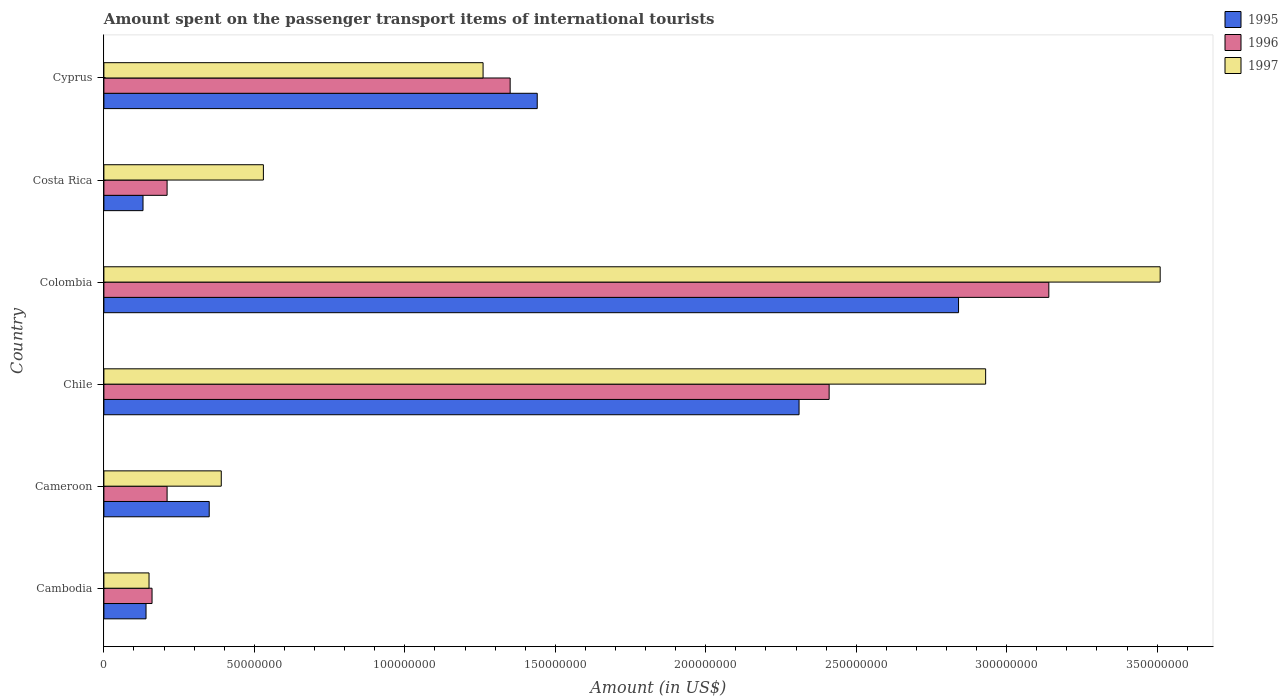How many groups of bars are there?
Offer a terse response. 6. Are the number of bars per tick equal to the number of legend labels?
Offer a terse response. Yes. How many bars are there on the 6th tick from the top?
Offer a very short reply. 3. How many bars are there on the 2nd tick from the bottom?
Offer a very short reply. 3. What is the label of the 5th group of bars from the top?
Make the answer very short. Cameroon. What is the amount spent on the passenger transport items of international tourists in 1995 in Chile?
Your answer should be very brief. 2.31e+08. Across all countries, what is the maximum amount spent on the passenger transport items of international tourists in 1996?
Your answer should be very brief. 3.14e+08. Across all countries, what is the minimum amount spent on the passenger transport items of international tourists in 1997?
Provide a succinct answer. 1.50e+07. In which country was the amount spent on the passenger transport items of international tourists in 1996 maximum?
Provide a succinct answer. Colombia. In which country was the amount spent on the passenger transport items of international tourists in 1997 minimum?
Ensure brevity in your answer.  Cambodia. What is the total amount spent on the passenger transport items of international tourists in 1995 in the graph?
Make the answer very short. 7.21e+08. What is the difference between the amount spent on the passenger transport items of international tourists in 1996 in Cameroon and that in Colombia?
Offer a terse response. -2.93e+08. What is the difference between the amount spent on the passenger transport items of international tourists in 1995 in Cyprus and the amount spent on the passenger transport items of international tourists in 1996 in Cambodia?
Give a very brief answer. 1.28e+08. What is the average amount spent on the passenger transport items of international tourists in 1995 per country?
Make the answer very short. 1.20e+08. What is the difference between the amount spent on the passenger transport items of international tourists in 1996 and amount spent on the passenger transport items of international tourists in 1995 in Cameroon?
Keep it short and to the point. -1.40e+07. In how many countries, is the amount spent on the passenger transport items of international tourists in 1996 greater than 90000000 US$?
Your answer should be compact. 3. What is the ratio of the amount spent on the passenger transport items of international tourists in 1997 in Cambodia to that in Cameroon?
Provide a short and direct response. 0.38. Is the difference between the amount spent on the passenger transport items of international tourists in 1996 in Cambodia and Cameroon greater than the difference between the amount spent on the passenger transport items of international tourists in 1995 in Cambodia and Cameroon?
Provide a short and direct response. Yes. What is the difference between the highest and the second highest amount spent on the passenger transport items of international tourists in 1997?
Keep it short and to the point. 5.80e+07. What is the difference between the highest and the lowest amount spent on the passenger transport items of international tourists in 1995?
Your answer should be compact. 2.71e+08. What does the 1st bar from the top in Colombia represents?
Offer a very short reply. 1997. What does the 1st bar from the bottom in Cameroon represents?
Your answer should be very brief. 1995. Is it the case that in every country, the sum of the amount spent on the passenger transport items of international tourists in 1996 and amount spent on the passenger transport items of international tourists in 1997 is greater than the amount spent on the passenger transport items of international tourists in 1995?
Provide a succinct answer. Yes. How many bars are there?
Give a very brief answer. 18. Are all the bars in the graph horizontal?
Provide a succinct answer. Yes. Are the values on the major ticks of X-axis written in scientific E-notation?
Ensure brevity in your answer.  No. Does the graph contain any zero values?
Ensure brevity in your answer.  No. Where does the legend appear in the graph?
Offer a terse response. Top right. How many legend labels are there?
Provide a succinct answer. 3. What is the title of the graph?
Offer a terse response. Amount spent on the passenger transport items of international tourists. What is the label or title of the Y-axis?
Offer a terse response. Country. What is the Amount (in US$) of 1995 in Cambodia?
Provide a succinct answer. 1.40e+07. What is the Amount (in US$) in 1996 in Cambodia?
Make the answer very short. 1.60e+07. What is the Amount (in US$) in 1997 in Cambodia?
Your answer should be very brief. 1.50e+07. What is the Amount (in US$) in 1995 in Cameroon?
Keep it short and to the point. 3.50e+07. What is the Amount (in US$) in 1996 in Cameroon?
Your answer should be compact. 2.10e+07. What is the Amount (in US$) of 1997 in Cameroon?
Make the answer very short. 3.90e+07. What is the Amount (in US$) in 1995 in Chile?
Give a very brief answer. 2.31e+08. What is the Amount (in US$) in 1996 in Chile?
Your answer should be compact. 2.41e+08. What is the Amount (in US$) of 1997 in Chile?
Provide a short and direct response. 2.93e+08. What is the Amount (in US$) in 1995 in Colombia?
Your answer should be very brief. 2.84e+08. What is the Amount (in US$) of 1996 in Colombia?
Ensure brevity in your answer.  3.14e+08. What is the Amount (in US$) of 1997 in Colombia?
Offer a terse response. 3.51e+08. What is the Amount (in US$) of 1995 in Costa Rica?
Give a very brief answer. 1.30e+07. What is the Amount (in US$) in 1996 in Costa Rica?
Your answer should be very brief. 2.10e+07. What is the Amount (in US$) in 1997 in Costa Rica?
Provide a short and direct response. 5.30e+07. What is the Amount (in US$) of 1995 in Cyprus?
Your answer should be compact. 1.44e+08. What is the Amount (in US$) in 1996 in Cyprus?
Your response must be concise. 1.35e+08. What is the Amount (in US$) of 1997 in Cyprus?
Provide a short and direct response. 1.26e+08. Across all countries, what is the maximum Amount (in US$) of 1995?
Your answer should be very brief. 2.84e+08. Across all countries, what is the maximum Amount (in US$) in 1996?
Offer a terse response. 3.14e+08. Across all countries, what is the maximum Amount (in US$) in 1997?
Keep it short and to the point. 3.51e+08. Across all countries, what is the minimum Amount (in US$) in 1995?
Provide a succinct answer. 1.30e+07. Across all countries, what is the minimum Amount (in US$) of 1996?
Give a very brief answer. 1.60e+07. Across all countries, what is the minimum Amount (in US$) in 1997?
Your response must be concise. 1.50e+07. What is the total Amount (in US$) of 1995 in the graph?
Your answer should be very brief. 7.21e+08. What is the total Amount (in US$) of 1996 in the graph?
Provide a succinct answer. 7.48e+08. What is the total Amount (in US$) in 1997 in the graph?
Provide a succinct answer. 8.77e+08. What is the difference between the Amount (in US$) in 1995 in Cambodia and that in Cameroon?
Ensure brevity in your answer.  -2.10e+07. What is the difference between the Amount (in US$) of 1996 in Cambodia and that in Cameroon?
Your answer should be very brief. -5.00e+06. What is the difference between the Amount (in US$) in 1997 in Cambodia and that in Cameroon?
Your answer should be very brief. -2.40e+07. What is the difference between the Amount (in US$) of 1995 in Cambodia and that in Chile?
Your response must be concise. -2.17e+08. What is the difference between the Amount (in US$) of 1996 in Cambodia and that in Chile?
Give a very brief answer. -2.25e+08. What is the difference between the Amount (in US$) in 1997 in Cambodia and that in Chile?
Provide a succinct answer. -2.78e+08. What is the difference between the Amount (in US$) of 1995 in Cambodia and that in Colombia?
Your answer should be compact. -2.70e+08. What is the difference between the Amount (in US$) in 1996 in Cambodia and that in Colombia?
Provide a succinct answer. -2.98e+08. What is the difference between the Amount (in US$) in 1997 in Cambodia and that in Colombia?
Keep it short and to the point. -3.36e+08. What is the difference between the Amount (in US$) in 1996 in Cambodia and that in Costa Rica?
Give a very brief answer. -5.00e+06. What is the difference between the Amount (in US$) of 1997 in Cambodia and that in Costa Rica?
Offer a terse response. -3.80e+07. What is the difference between the Amount (in US$) of 1995 in Cambodia and that in Cyprus?
Offer a terse response. -1.30e+08. What is the difference between the Amount (in US$) of 1996 in Cambodia and that in Cyprus?
Your answer should be very brief. -1.19e+08. What is the difference between the Amount (in US$) in 1997 in Cambodia and that in Cyprus?
Provide a succinct answer. -1.11e+08. What is the difference between the Amount (in US$) of 1995 in Cameroon and that in Chile?
Keep it short and to the point. -1.96e+08. What is the difference between the Amount (in US$) of 1996 in Cameroon and that in Chile?
Give a very brief answer. -2.20e+08. What is the difference between the Amount (in US$) in 1997 in Cameroon and that in Chile?
Ensure brevity in your answer.  -2.54e+08. What is the difference between the Amount (in US$) of 1995 in Cameroon and that in Colombia?
Offer a very short reply. -2.49e+08. What is the difference between the Amount (in US$) in 1996 in Cameroon and that in Colombia?
Make the answer very short. -2.93e+08. What is the difference between the Amount (in US$) of 1997 in Cameroon and that in Colombia?
Ensure brevity in your answer.  -3.12e+08. What is the difference between the Amount (in US$) of 1995 in Cameroon and that in Costa Rica?
Your answer should be compact. 2.20e+07. What is the difference between the Amount (in US$) in 1996 in Cameroon and that in Costa Rica?
Your answer should be compact. 0. What is the difference between the Amount (in US$) in 1997 in Cameroon and that in Costa Rica?
Provide a short and direct response. -1.40e+07. What is the difference between the Amount (in US$) in 1995 in Cameroon and that in Cyprus?
Your response must be concise. -1.09e+08. What is the difference between the Amount (in US$) in 1996 in Cameroon and that in Cyprus?
Offer a terse response. -1.14e+08. What is the difference between the Amount (in US$) in 1997 in Cameroon and that in Cyprus?
Keep it short and to the point. -8.70e+07. What is the difference between the Amount (in US$) of 1995 in Chile and that in Colombia?
Give a very brief answer. -5.30e+07. What is the difference between the Amount (in US$) in 1996 in Chile and that in Colombia?
Provide a succinct answer. -7.30e+07. What is the difference between the Amount (in US$) in 1997 in Chile and that in Colombia?
Your response must be concise. -5.80e+07. What is the difference between the Amount (in US$) of 1995 in Chile and that in Costa Rica?
Make the answer very short. 2.18e+08. What is the difference between the Amount (in US$) in 1996 in Chile and that in Costa Rica?
Give a very brief answer. 2.20e+08. What is the difference between the Amount (in US$) in 1997 in Chile and that in Costa Rica?
Your response must be concise. 2.40e+08. What is the difference between the Amount (in US$) in 1995 in Chile and that in Cyprus?
Offer a terse response. 8.70e+07. What is the difference between the Amount (in US$) of 1996 in Chile and that in Cyprus?
Offer a very short reply. 1.06e+08. What is the difference between the Amount (in US$) in 1997 in Chile and that in Cyprus?
Provide a short and direct response. 1.67e+08. What is the difference between the Amount (in US$) of 1995 in Colombia and that in Costa Rica?
Give a very brief answer. 2.71e+08. What is the difference between the Amount (in US$) of 1996 in Colombia and that in Costa Rica?
Your answer should be compact. 2.93e+08. What is the difference between the Amount (in US$) in 1997 in Colombia and that in Costa Rica?
Make the answer very short. 2.98e+08. What is the difference between the Amount (in US$) of 1995 in Colombia and that in Cyprus?
Make the answer very short. 1.40e+08. What is the difference between the Amount (in US$) of 1996 in Colombia and that in Cyprus?
Keep it short and to the point. 1.79e+08. What is the difference between the Amount (in US$) of 1997 in Colombia and that in Cyprus?
Offer a very short reply. 2.25e+08. What is the difference between the Amount (in US$) in 1995 in Costa Rica and that in Cyprus?
Your response must be concise. -1.31e+08. What is the difference between the Amount (in US$) in 1996 in Costa Rica and that in Cyprus?
Offer a very short reply. -1.14e+08. What is the difference between the Amount (in US$) in 1997 in Costa Rica and that in Cyprus?
Your answer should be compact. -7.30e+07. What is the difference between the Amount (in US$) of 1995 in Cambodia and the Amount (in US$) of 1996 in Cameroon?
Your answer should be very brief. -7.00e+06. What is the difference between the Amount (in US$) of 1995 in Cambodia and the Amount (in US$) of 1997 in Cameroon?
Your answer should be very brief. -2.50e+07. What is the difference between the Amount (in US$) of 1996 in Cambodia and the Amount (in US$) of 1997 in Cameroon?
Offer a very short reply. -2.30e+07. What is the difference between the Amount (in US$) of 1995 in Cambodia and the Amount (in US$) of 1996 in Chile?
Provide a succinct answer. -2.27e+08. What is the difference between the Amount (in US$) of 1995 in Cambodia and the Amount (in US$) of 1997 in Chile?
Your response must be concise. -2.79e+08. What is the difference between the Amount (in US$) in 1996 in Cambodia and the Amount (in US$) in 1997 in Chile?
Your answer should be very brief. -2.77e+08. What is the difference between the Amount (in US$) in 1995 in Cambodia and the Amount (in US$) in 1996 in Colombia?
Your response must be concise. -3.00e+08. What is the difference between the Amount (in US$) in 1995 in Cambodia and the Amount (in US$) in 1997 in Colombia?
Ensure brevity in your answer.  -3.37e+08. What is the difference between the Amount (in US$) in 1996 in Cambodia and the Amount (in US$) in 1997 in Colombia?
Your answer should be very brief. -3.35e+08. What is the difference between the Amount (in US$) of 1995 in Cambodia and the Amount (in US$) of 1996 in Costa Rica?
Keep it short and to the point. -7.00e+06. What is the difference between the Amount (in US$) of 1995 in Cambodia and the Amount (in US$) of 1997 in Costa Rica?
Provide a short and direct response. -3.90e+07. What is the difference between the Amount (in US$) of 1996 in Cambodia and the Amount (in US$) of 1997 in Costa Rica?
Provide a short and direct response. -3.70e+07. What is the difference between the Amount (in US$) in 1995 in Cambodia and the Amount (in US$) in 1996 in Cyprus?
Keep it short and to the point. -1.21e+08. What is the difference between the Amount (in US$) in 1995 in Cambodia and the Amount (in US$) in 1997 in Cyprus?
Offer a terse response. -1.12e+08. What is the difference between the Amount (in US$) in 1996 in Cambodia and the Amount (in US$) in 1997 in Cyprus?
Offer a terse response. -1.10e+08. What is the difference between the Amount (in US$) of 1995 in Cameroon and the Amount (in US$) of 1996 in Chile?
Provide a short and direct response. -2.06e+08. What is the difference between the Amount (in US$) of 1995 in Cameroon and the Amount (in US$) of 1997 in Chile?
Offer a very short reply. -2.58e+08. What is the difference between the Amount (in US$) in 1996 in Cameroon and the Amount (in US$) in 1997 in Chile?
Your answer should be very brief. -2.72e+08. What is the difference between the Amount (in US$) of 1995 in Cameroon and the Amount (in US$) of 1996 in Colombia?
Keep it short and to the point. -2.79e+08. What is the difference between the Amount (in US$) in 1995 in Cameroon and the Amount (in US$) in 1997 in Colombia?
Provide a short and direct response. -3.16e+08. What is the difference between the Amount (in US$) in 1996 in Cameroon and the Amount (in US$) in 1997 in Colombia?
Provide a short and direct response. -3.30e+08. What is the difference between the Amount (in US$) in 1995 in Cameroon and the Amount (in US$) in 1996 in Costa Rica?
Offer a terse response. 1.40e+07. What is the difference between the Amount (in US$) in 1995 in Cameroon and the Amount (in US$) in 1997 in Costa Rica?
Your response must be concise. -1.80e+07. What is the difference between the Amount (in US$) in 1996 in Cameroon and the Amount (in US$) in 1997 in Costa Rica?
Give a very brief answer. -3.20e+07. What is the difference between the Amount (in US$) in 1995 in Cameroon and the Amount (in US$) in 1996 in Cyprus?
Offer a very short reply. -1.00e+08. What is the difference between the Amount (in US$) in 1995 in Cameroon and the Amount (in US$) in 1997 in Cyprus?
Offer a terse response. -9.10e+07. What is the difference between the Amount (in US$) of 1996 in Cameroon and the Amount (in US$) of 1997 in Cyprus?
Make the answer very short. -1.05e+08. What is the difference between the Amount (in US$) of 1995 in Chile and the Amount (in US$) of 1996 in Colombia?
Your response must be concise. -8.30e+07. What is the difference between the Amount (in US$) of 1995 in Chile and the Amount (in US$) of 1997 in Colombia?
Ensure brevity in your answer.  -1.20e+08. What is the difference between the Amount (in US$) in 1996 in Chile and the Amount (in US$) in 1997 in Colombia?
Keep it short and to the point. -1.10e+08. What is the difference between the Amount (in US$) of 1995 in Chile and the Amount (in US$) of 1996 in Costa Rica?
Your answer should be compact. 2.10e+08. What is the difference between the Amount (in US$) of 1995 in Chile and the Amount (in US$) of 1997 in Costa Rica?
Your answer should be very brief. 1.78e+08. What is the difference between the Amount (in US$) of 1996 in Chile and the Amount (in US$) of 1997 in Costa Rica?
Provide a succinct answer. 1.88e+08. What is the difference between the Amount (in US$) of 1995 in Chile and the Amount (in US$) of 1996 in Cyprus?
Your answer should be very brief. 9.60e+07. What is the difference between the Amount (in US$) of 1995 in Chile and the Amount (in US$) of 1997 in Cyprus?
Your answer should be compact. 1.05e+08. What is the difference between the Amount (in US$) in 1996 in Chile and the Amount (in US$) in 1997 in Cyprus?
Provide a short and direct response. 1.15e+08. What is the difference between the Amount (in US$) in 1995 in Colombia and the Amount (in US$) in 1996 in Costa Rica?
Make the answer very short. 2.63e+08. What is the difference between the Amount (in US$) in 1995 in Colombia and the Amount (in US$) in 1997 in Costa Rica?
Provide a succinct answer. 2.31e+08. What is the difference between the Amount (in US$) in 1996 in Colombia and the Amount (in US$) in 1997 in Costa Rica?
Your answer should be very brief. 2.61e+08. What is the difference between the Amount (in US$) in 1995 in Colombia and the Amount (in US$) in 1996 in Cyprus?
Offer a terse response. 1.49e+08. What is the difference between the Amount (in US$) in 1995 in Colombia and the Amount (in US$) in 1997 in Cyprus?
Your response must be concise. 1.58e+08. What is the difference between the Amount (in US$) of 1996 in Colombia and the Amount (in US$) of 1997 in Cyprus?
Give a very brief answer. 1.88e+08. What is the difference between the Amount (in US$) of 1995 in Costa Rica and the Amount (in US$) of 1996 in Cyprus?
Ensure brevity in your answer.  -1.22e+08. What is the difference between the Amount (in US$) in 1995 in Costa Rica and the Amount (in US$) in 1997 in Cyprus?
Make the answer very short. -1.13e+08. What is the difference between the Amount (in US$) in 1996 in Costa Rica and the Amount (in US$) in 1997 in Cyprus?
Your response must be concise. -1.05e+08. What is the average Amount (in US$) of 1995 per country?
Your answer should be compact. 1.20e+08. What is the average Amount (in US$) of 1996 per country?
Provide a succinct answer. 1.25e+08. What is the average Amount (in US$) of 1997 per country?
Make the answer very short. 1.46e+08. What is the difference between the Amount (in US$) of 1995 and Amount (in US$) of 1996 in Cambodia?
Offer a terse response. -2.00e+06. What is the difference between the Amount (in US$) of 1995 and Amount (in US$) of 1997 in Cambodia?
Ensure brevity in your answer.  -1.00e+06. What is the difference between the Amount (in US$) in 1995 and Amount (in US$) in 1996 in Cameroon?
Your answer should be compact. 1.40e+07. What is the difference between the Amount (in US$) of 1995 and Amount (in US$) of 1997 in Cameroon?
Make the answer very short. -4.00e+06. What is the difference between the Amount (in US$) of 1996 and Amount (in US$) of 1997 in Cameroon?
Offer a terse response. -1.80e+07. What is the difference between the Amount (in US$) of 1995 and Amount (in US$) of 1996 in Chile?
Give a very brief answer. -1.00e+07. What is the difference between the Amount (in US$) in 1995 and Amount (in US$) in 1997 in Chile?
Your answer should be very brief. -6.20e+07. What is the difference between the Amount (in US$) in 1996 and Amount (in US$) in 1997 in Chile?
Your answer should be very brief. -5.20e+07. What is the difference between the Amount (in US$) of 1995 and Amount (in US$) of 1996 in Colombia?
Provide a succinct answer. -3.00e+07. What is the difference between the Amount (in US$) in 1995 and Amount (in US$) in 1997 in Colombia?
Your response must be concise. -6.70e+07. What is the difference between the Amount (in US$) in 1996 and Amount (in US$) in 1997 in Colombia?
Your response must be concise. -3.70e+07. What is the difference between the Amount (in US$) of 1995 and Amount (in US$) of 1996 in Costa Rica?
Provide a short and direct response. -8.00e+06. What is the difference between the Amount (in US$) of 1995 and Amount (in US$) of 1997 in Costa Rica?
Offer a terse response. -4.00e+07. What is the difference between the Amount (in US$) in 1996 and Amount (in US$) in 1997 in Costa Rica?
Your response must be concise. -3.20e+07. What is the difference between the Amount (in US$) in 1995 and Amount (in US$) in 1996 in Cyprus?
Your response must be concise. 9.00e+06. What is the difference between the Amount (in US$) in 1995 and Amount (in US$) in 1997 in Cyprus?
Give a very brief answer. 1.80e+07. What is the difference between the Amount (in US$) of 1996 and Amount (in US$) of 1997 in Cyprus?
Your answer should be compact. 9.00e+06. What is the ratio of the Amount (in US$) in 1996 in Cambodia to that in Cameroon?
Offer a terse response. 0.76. What is the ratio of the Amount (in US$) in 1997 in Cambodia to that in Cameroon?
Make the answer very short. 0.38. What is the ratio of the Amount (in US$) of 1995 in Cambodia to that in Chile?
Make the answer very short. 0.06. What is the ratio of the Amount (in US$) in 1996 in Cambodia to that in Chile?
Provide a short and direct response. 0.07. What is the ratio of the Amount (in US$) in 1997 in Cambodia to that in Chile?
Keep it short and to the point. 0.05. What is the ratio of the Amount (in US$) of 1995 in Cambodia to that in Colombia?
Give a very brief answer. 0.05. What is the ratio of the Amount (in US$) of 1996 in Cambodia to that in Colombia?
Your answer should be very brief. 0.05. What is the ratio of the Amount (in US$) of 1997 in Cambodia to that in Colombia?
Your answer should be very brief. 0.04. What is the ratio of the Amount (in US$) in 1996 in Cambodia to that in Costa Rica?
Keep it short and to the point. 0.76. What is the ratio of the Amount (in US$) in 1997 in Cambodia to that in Costa Rica?
Provide a short and direct response. 0.28. What is the ratio of the Amount (in US$) of 1995 in Cambodia to that in Cyprus?
Keep it short and to the point. 0.1. What is the ratio of the Amount (in US$) of 1996 in Cambodia to that in Cyprus?
Offer a terse response. 0.12. What is the ratio of the Amount (in US$) in 1997 in Cambodia to that in Cyprus?
Ensure brevity in your answer.  0.12. What is the ratio of the Amount (in US$) of 1995 in Cameroon to that in Chile?
Provide a succinct answer. 0.15. What is the ratio of the Amount (in US$) in 1996 in Cameroon to that in Chile?
Your response must be concise. 0.09. What is the ratio of the Amount (in US$) in 1997 in Cameroon to that in Chile?
Your answer should be very brief. 0.13. What is the ratio of the Amount (in US$) of 1995 in Cameroon to that in Colombia?
Your response must be concise. 0.12. What is the ratio of the Amount (in US$) of 1996 in Cameroon to that in Colombia?
Your answer should be very brief. 0.07. What is the ratio of the Amount (in US$) in 1995 in Cameroon to that in Costa Rica?
Keep it short and to the point. 2.69. What is the ratio of the Amount (in US$) in 1997 in Cameroon to that in Costa Rica?
Offer a terse response. 0.74. What is the ratio of the Amount (in US$) of 1995 in Cameroon to that in Cyprus?
Your response must be concise. 0.24. What is the ratio of the Amount (in US$) in 1996 in Cameroon to that in Cyprus?
Your response must be concise. 0.16. What is the ratio of the Amount (in US$) of 1997 in Cameroon to that in Cyprus?
Your response must be concise. 0.31. What is the ratio of the Amount (in US$) in 1995 in Chile to that in Colombia?
Provide a short and direct response. 0.81. What is the ratio of the Amount (in US$) in 1996 in Chile to that in Colombia?
Your response must be concise. 0.77. What is the ratio of the Amount (in US$) in 1997 in Chile to that in Colombia?
Keep it short and to the point. 0.83. What is the ratio of the Amount (in US$) in 1995 in Chile to that in Costa Rica?
Provide a succinct answer. 17.77. What is the ratio of the Amount (in US$) of 1996 in Chile to that in Costa Rica?
Provide a succinct answer. 11.48. What is the ratio of the Amount (in US$) in 1997 in Chile to that in Costa Rica?
Offer a very short reply. 5.53. What is the ratio of the Amount (in US$) in 1995 in Chile to that in Cyprus?
Give a very brief answer. 1.6. What is the ratio of the Amount (in US$) in 1996 in Chile to that in Cyprus?
Your response must be concise. 1.79. What is the ratio of the Amount (in US$) of 1997 in Chile to that in Cyprus?
Keep it short and to the point. 2.33. What is the ratio of the Amount (in US$) in 1995 in Colombia to that in Costa Rica?
Keep it short and to the point. 21.85. What is the ratio of the Amount (in US$) of 1996 in Colombia to that in Costa Rica?
Keep it short and to the point. 14.95. What is the ratio of the Amount (in US$) of 1997 in Colombia to that in Costa Rica?
Ensure brevity in your answer.  6.62. What is the ratio of the Amount (in US$) in 1995 in Colombia to that in Cyprus?
Your response must be concise. 1.97. What is the ratio of the Amount (in US$) in 1996 in Colombia to that in Cyprus?
Make the answer very short. 2.33. What is the ratio of the Amount (in US$) of 1997 in Colombia to that in Cyprus?
Provide a succinct answer. 2.79. What is the ratio of the Amount (in US$) in 1995 in Costa Rica to that in Cyprus?
Give a very brief answer. 0.09. What is the ratio of the Amount (in US$) of 1996 in Costa Rica to that in Cyprus?
Your answer should be compact. 0.16. What is the ratio of the Amount (in US$) in 1997 in Costa Rica to that in Cyprus?
Provide a short and direct response. 0.42. What is the difference between the highest and the second highest Amount (in US$) of 1995?
Your response must be concise. 5.30e+07. What is the difference between the highest and the second highest Amount (in US$) in 1996?
Keep it short and to the point. 7.30e+07. What is the difference between the highest and the second highest Amount (in US$) of 1997?
Your answer should be very brief. 5.80e+07. What is the difference between the highest and the lowest Amount (in US$) in 1995?
Give a very brief answer. 2.71e+08. What is the difference between the highest and the lowest Amount (in US$) in 1996?
Offer a very short reply. 2.98e+08. What is the difference between the highest and the lowest Amount (in US$) of 1997?
Your response must be concise. 3.36e+08. 